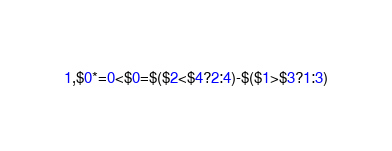<code> <loc_0><loc_0><loc_500><loc_500><_Awk_>1,$0*=0<$0=$($2<$4?2:4)-$($1>$3?1:3)</code> 